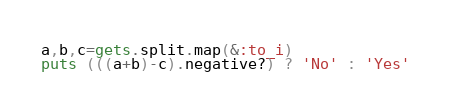Convert code to text. <code><loc_0><loc_0><loc_500><loc_500><_Ruby_>a,b,c=gets.split.map(&:to_i)
puts (((a+b)-c).negative?) ? 'No' : 'Yes'</code> 